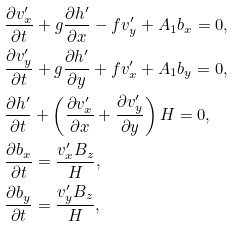Convert formula to latex. <formula><loc_0><loc_0><loc_500><loc_500>& \frac { \partial v ^ { \prime } _ { x } } { \partial t } + g \frac { \partial h ^ { \prime } } { \partial x } - f v ^ { \prime } _ { y } + A _ { 1 } b _ { x } = 0 , \\ & \frac { \partial v ^ { \prime } _ { y } } { \partial t } + g \frac { \partial h ^ { \prime } } { \partial y } + f v ^ { \prime } _ { x } + A _ { 1 } b _ { y } = 0 , \\ & \frac { \partial h ^ { \prime } } { \partial t } + \left ( \frac { \partial v ^ { \prime } _ { x } } { \partial x } + \frac { \partial v ^ { \prime } _ { y } } { \partial y } \right ) H = 0 , \\ & \frac { \partial b _ { x } } { \partial t } = \frac { v ^ { \prime } _ { x } B _ { z } } { H } , \\ & \frac { \partial b _ { y } } { \partial t } = \frac { v ^ { \prime } _ { y } B _ { z } } { H } , \\</formula> 